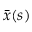<formula> <loc_0><loc_0><loc_500><loc_500>\bar { x } ( s )</formula> 